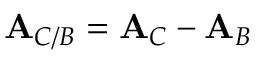<formula> <loc_0><loc_0><loc_500><loc_500>A _ { C / B } = A _ { C } - A _ { B }</formula> 